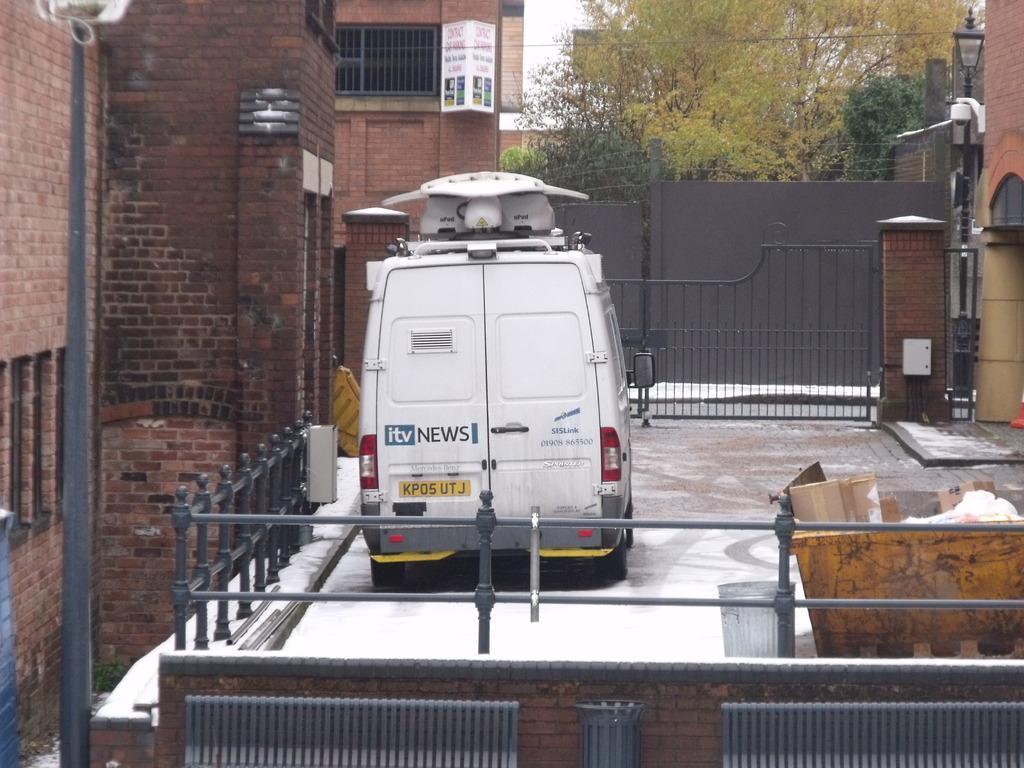Describe this image in one or two sentences. In the center of the image we can see a vehicle. At the bottom there is a wall. In the background there are buildings, poles, gates, trees, wires and sky. On the right there is a bin. 